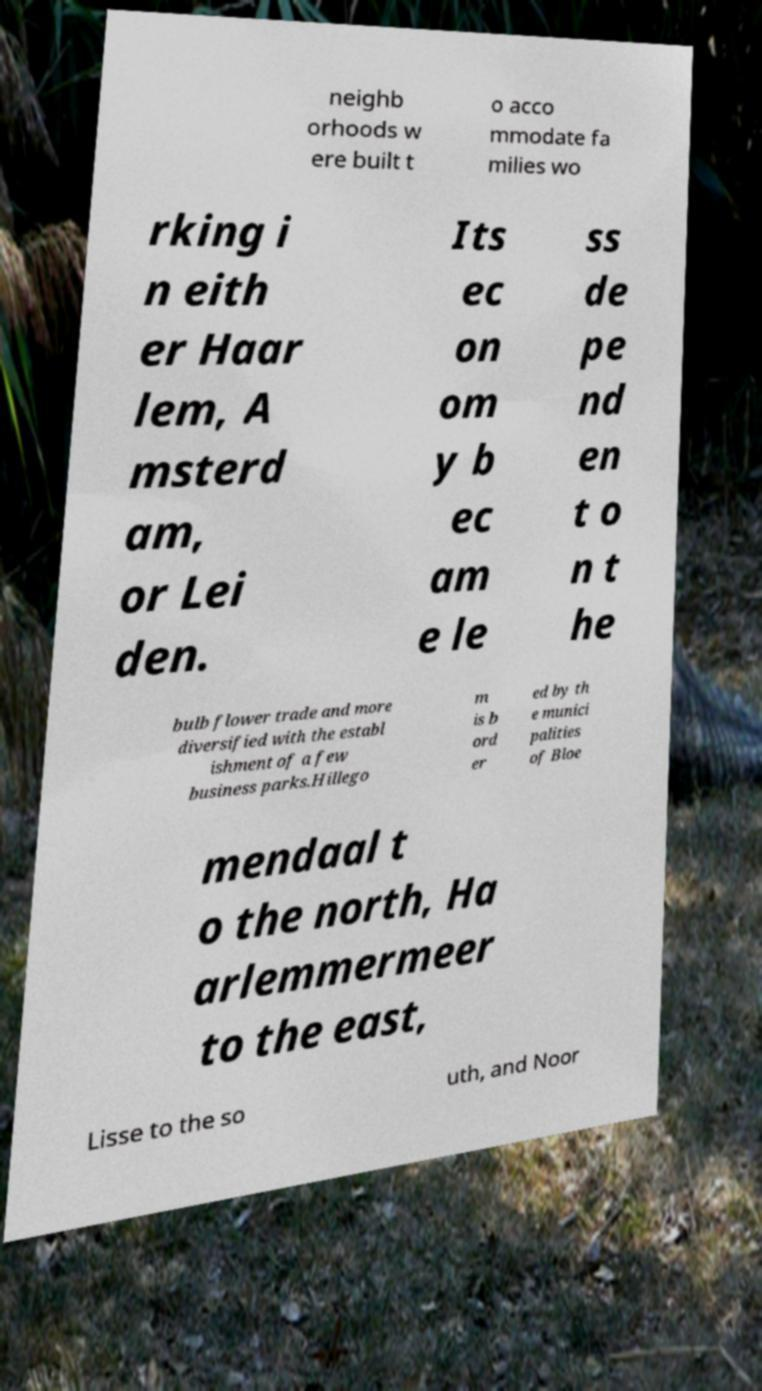Please read and relay the text visible in this image. What does it say? neighb orhoods w ere built t o acco mmodate fa milies wo rking i n eith er Haar lem, A msterd am, or Lei den. Its ec on om y b ec am e le ss de pe nd en t o n t he bulb flower trade and more diversified with the establ ishment of a few business parks.Hillego m is b ord er ed by th e munici palities of Bloe mendaal t o the north, Ha arlemmermeer to the east, Lisse to the so uth, and Noor 